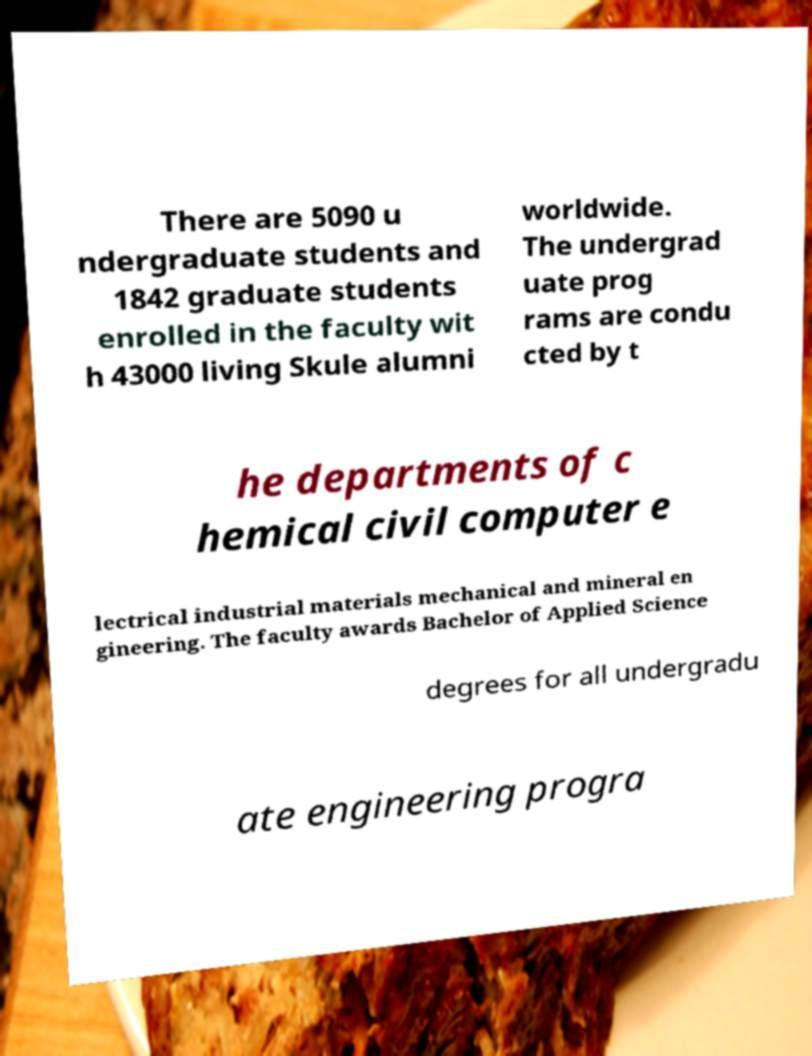What messages or text are displayed in this image? I need them in a readable, typed format. There are 5090 u ndergraduate students and 1842 graduate students enrolled in the faculty wit h 43000 living Skule alumni worldwide. The undergrad uate prog rams are condu cted by t he departments of c hemical civil computer e lectrical industrial materials mechanical and mineral en gineering. The faculty awards Bachelor of Applied Science degrees for all undergradu ate engineering progra 